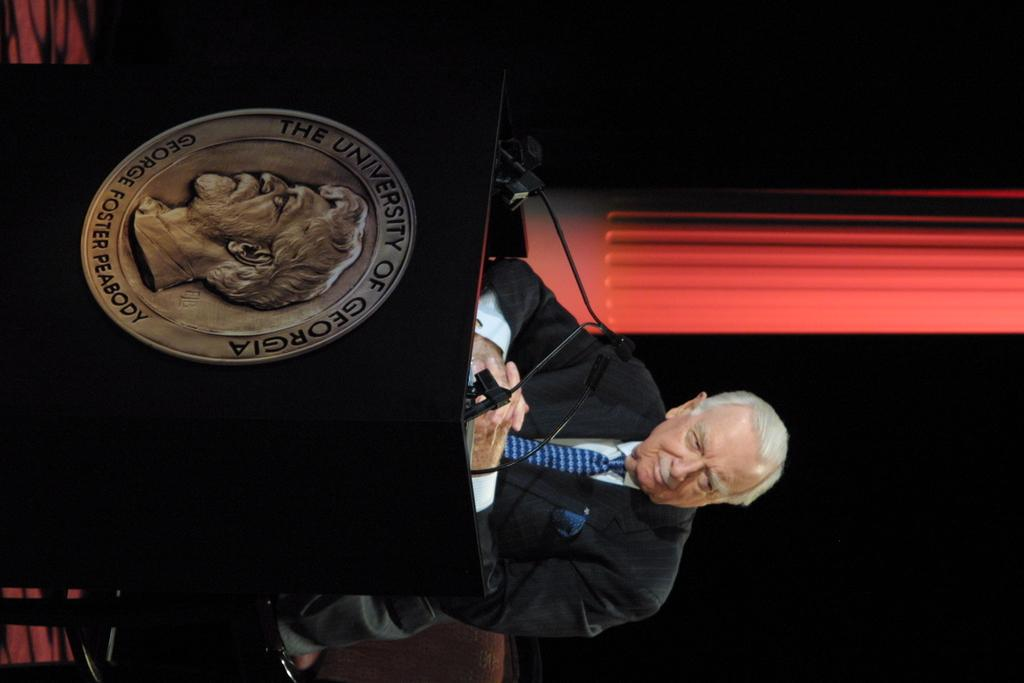<image>
Summarize the visual content of the image. A man is at a podium at the University of Georgia. 